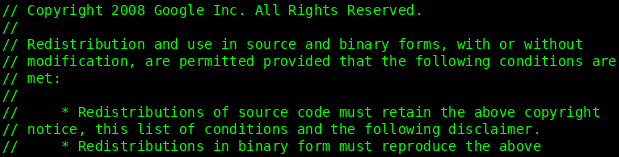Convert code to text. <code><loc_0><loc_0><loc_500><loc_500><_C_>// Copyright 2008 Google Inc. All Rights Reserved.
//
// Redistribution and use in source and binary forms, with or without
// modification, are permitted provided that the following conditions are
// met:
//
//     * Redistributions of source code must retain the above copyright
// notice, this list of conditions and the following disclaimer.
//     * Redistributions in binary form must reproduce the above</code> 